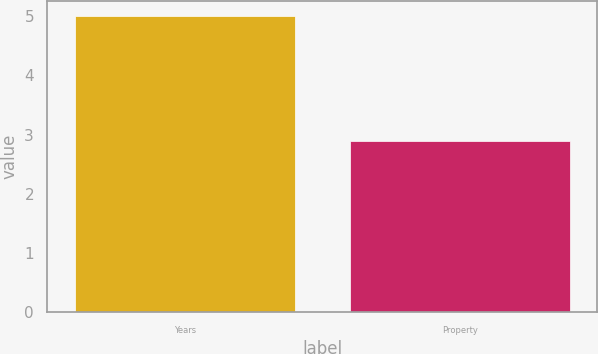Convert chart to OTSL. <chart><loc_0><loc_0><loc_500><loc_500><bar_chart><fcel>Years<fcel>Property<nl><fcel>5<fcel>2.9<nl></chart> 